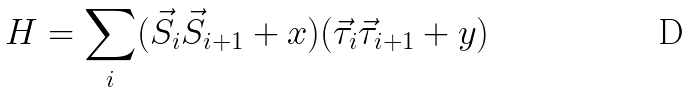<formula> <loc_0><loc_0><loc_500><loc_500>H = \sum _ { i } ( \vec { S } _ { i } \vec { S } _ { i + 1 } + x ) ( \vec { \tau } _ { i } \vec { \tau } _ { i + 1 } + y )</formula> 